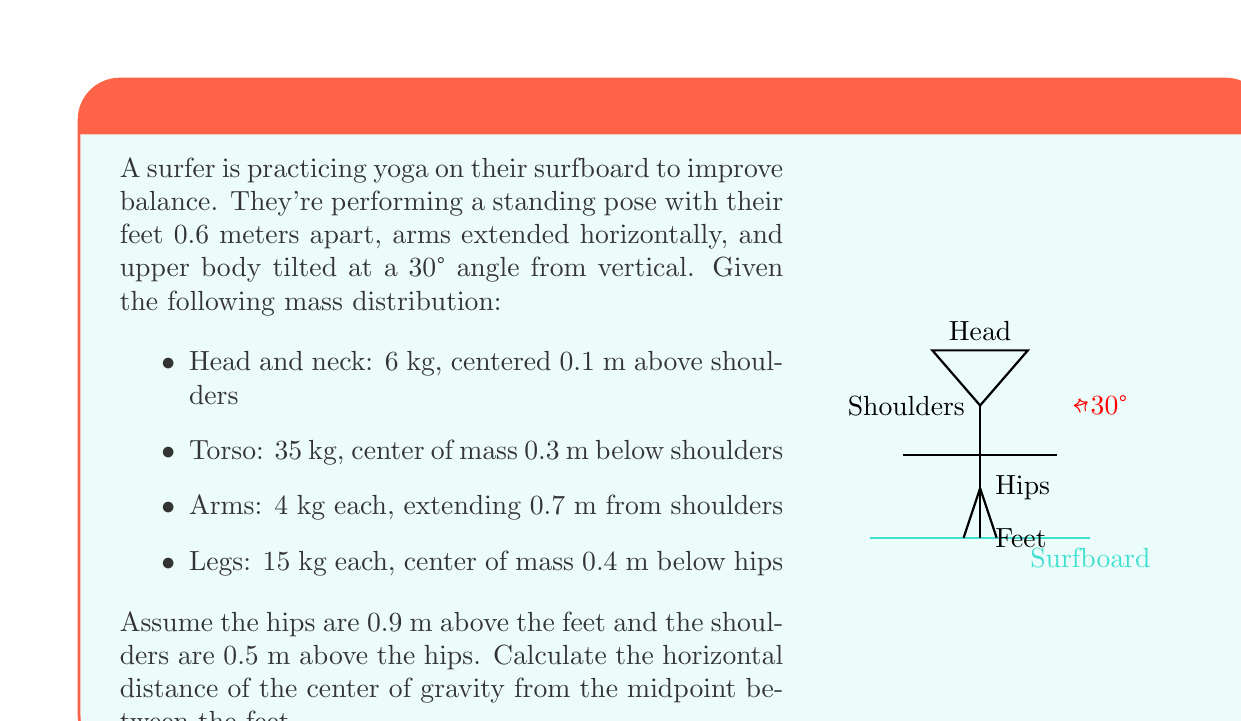Give your solution to this math problem. Let's approach this step-by-step:

1) First, we need to calculate the x-coordinate (horizontal distance) of each body part's center of mass from the midpoint between the feet:

   Head: $x_h = 0.5 \sin(30°) + 0.9 \sin(30°) + 0.1 \sin(30°) = 0.75$ m
   Torso: $x_t = 0.5 \sin(30°) + 0.45 \cos(30°) = 0.64$ m
   Arms: $x_a = 0.5 \sin(30°) + 0.9 \sin(30°) + 0.7 \cos(30°) = 1.36$ m
   Legs: $x_l = 0$ m (assumed to be directly above the midpoint)

2) Now, we can use the formula for the center of mass:

   $$x_{cm} = \frac{\sum m_i x_i}{\sum m_i}$$

   Where $m_i$ is the mass of each part and $x_i$ is its x-coordinate.

3) Let's substitute our values:

   $$x_{cm} = \frac{6(0.75) + 35(0.64) + 4(1.36) + 4(1.36) + 15(0) + 15(0)}{6 + 35 + 4 + 4 + 15 + 15}$$

4) Simplify:

   $$x_{cm} = \frac{4.5 + 22.4 + 5.44 + 5.44 + 0 + 0}{79} = \frac{37.78}{79}$$

5) Calculate the final result:

   $$x_{cm} = 0.478 \text{ m}$$

Therefore, the center of gravity is approximately 0.478 meters horizontally from the midpoint between the feet.
Answer: 0.478 m 